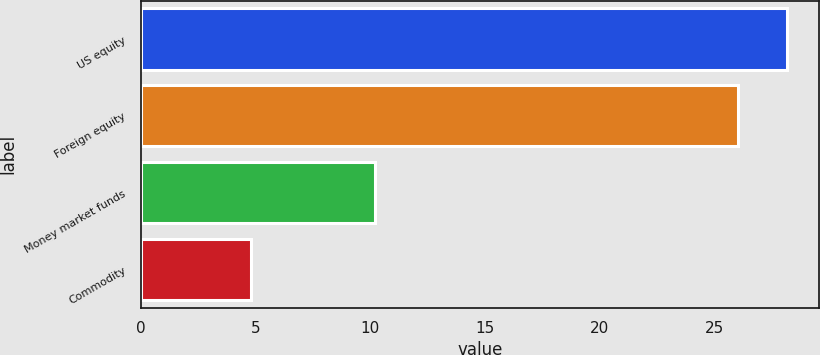Convert chart to OTSL. <chart><loc_0><loc_0><loc_500><loc_500><bar_chart><fcel>US equity<fcel>Foreign equity<fcel>Money market funds<fcel>Commodity<nl><fcel>28.13<fcel>26<fcel>10.2<fcel>4.8<nl></chart> 